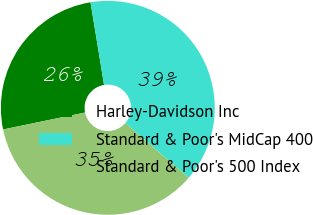Convert chart to OTSL. <chart><loc_0><loc_0><loc_500><loc_500><pie_chart><fcel>Harley-Davidson Inc<fcel>Standard & Poor's MidCap 400<fcel>Standard & Poor's 500 Index<nl><fcel>25.66%<fcel>38.94%<fcel>35.4%<nl></chart> 